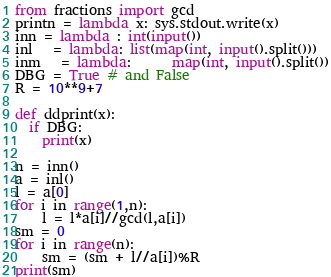<code> <loc_0><loc_0><loc_500><loc_500><_Python_>from fractions import gcd
printn = lambda x: sys.stdout.write(x)
inn = lambda : int(input())
inl   = lambda: list(map(int, input().split()))
inm   = lambda:      map(int, input().split())
DBG = True # and False
R = 10**9+7

def ddprint(x):
  if DBG:
    print(x)

n = inn()
a = inl()
l = a[0]
for i in range(1,n):
    l = l*a[i]//gcd(l,a[i])
sm = 0
for i in range(n):
    sm = (sm + l//a[i])%R
print(sm)
</code> 